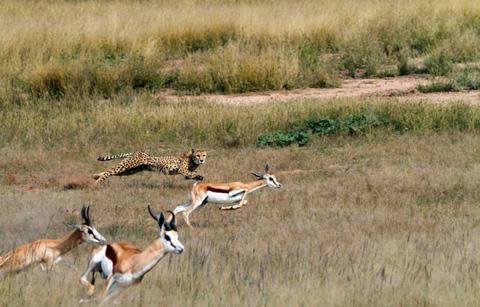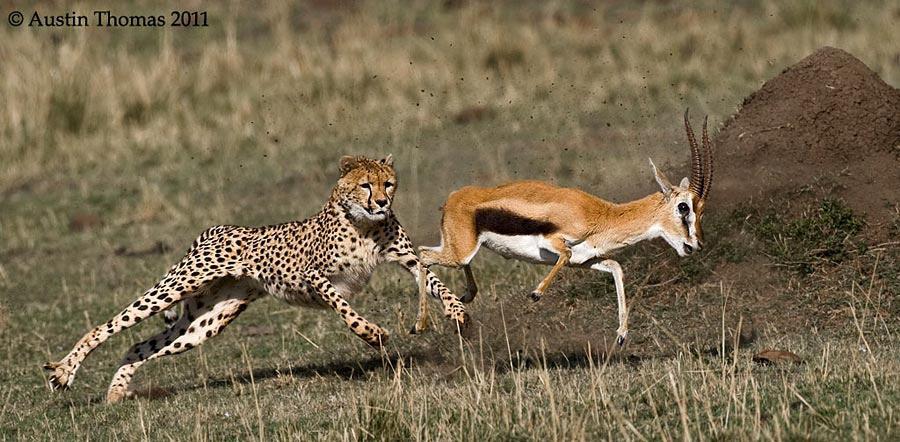The first image is the image on the left, the second image is the image on the right. Given the left and right images, does the statement "One image includes more than one spotted cat on the ground." hold true? Answer yes or no. No. The first image is the image on the left, the second image is the image on the right. Considering the images on both sides, is "There are exactly two animals in the image on the left." valid? Answer yes or no. No. 